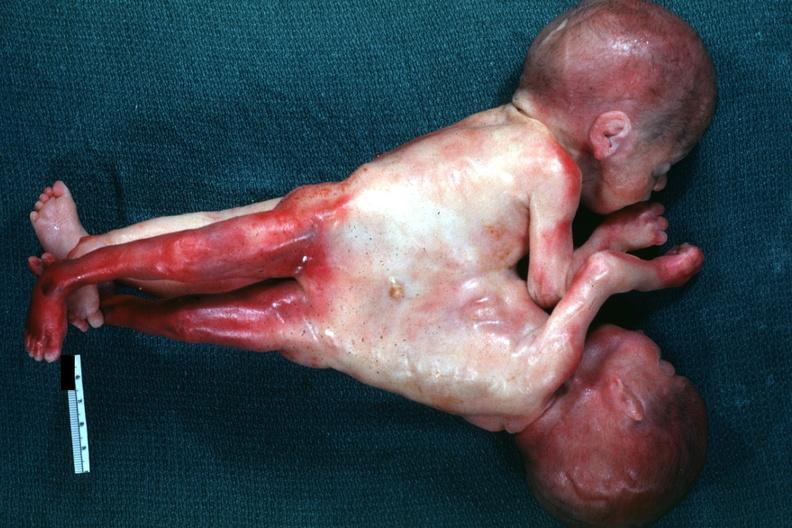what joined abdomen and lower chest anterior?
Answer the question using a single word or phrase. Very good example 